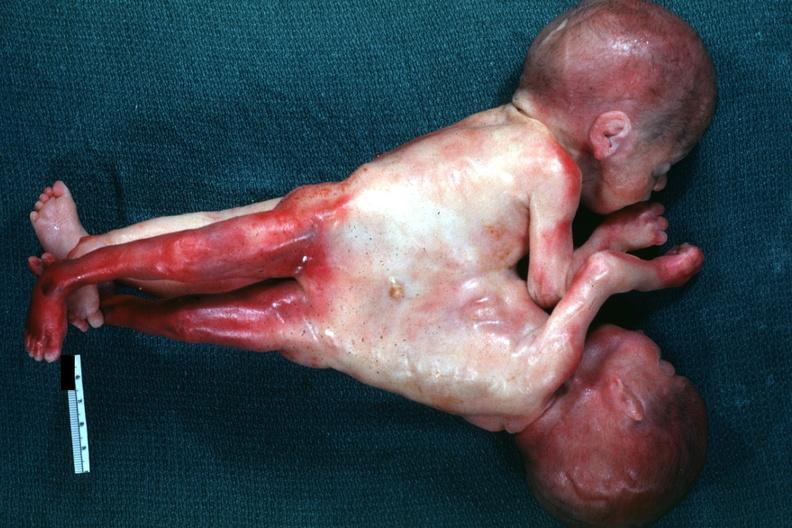what joined abdomen and lower chest anterior?
Answer the question using a single word or phrase. Very good example 